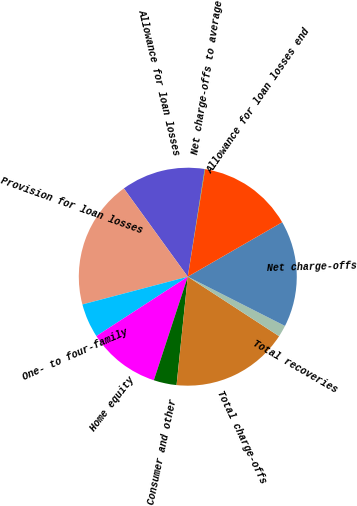Convert chart to OTSL. <chart><loc_0><loc_0><loc_500><loc_500><pie_chart><fcel>Allowance for loan losses<fcel>Provision for loan losses<fcel>One- to four-family<fcel>Home equity<fcel>Consumer and other<fcel>Total charge-offs<fcel>Total recoveries<fcel>Net charge-offs<fcel>Allowance for loan losses end<fcel>Net charge-offs to average<nl><fcel>12.46%<fcel>19.12%<fcel>5.07%<fcel>10.79%<fcel>3.4%<fcel>17.45%<fcel>1.73%<fcel>15.79%<fcel>14.12%<fcel>0.07%<nl></chart> 